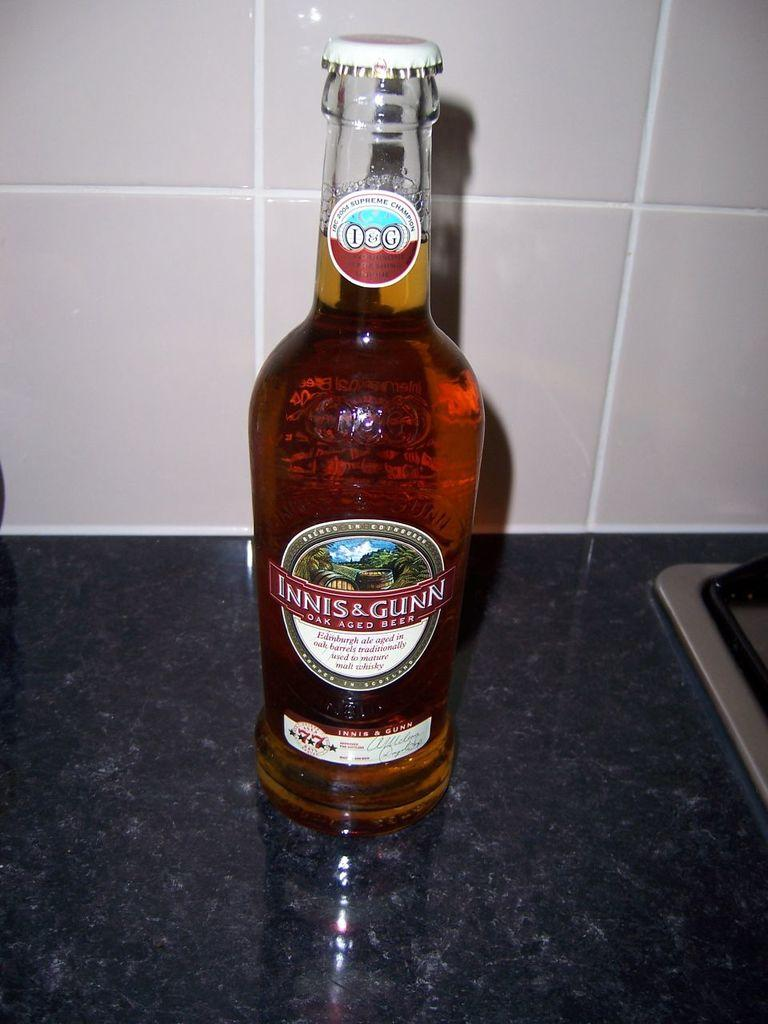What type of container is visible in the image? There is a glass bottle in the image. What is written on the bottle? The words "INNIS & GUNN" are written on the bottle. Is the bottle sinking in quicksand in the image? There is no quicksand present in the image, and the bottle is not sinking. 